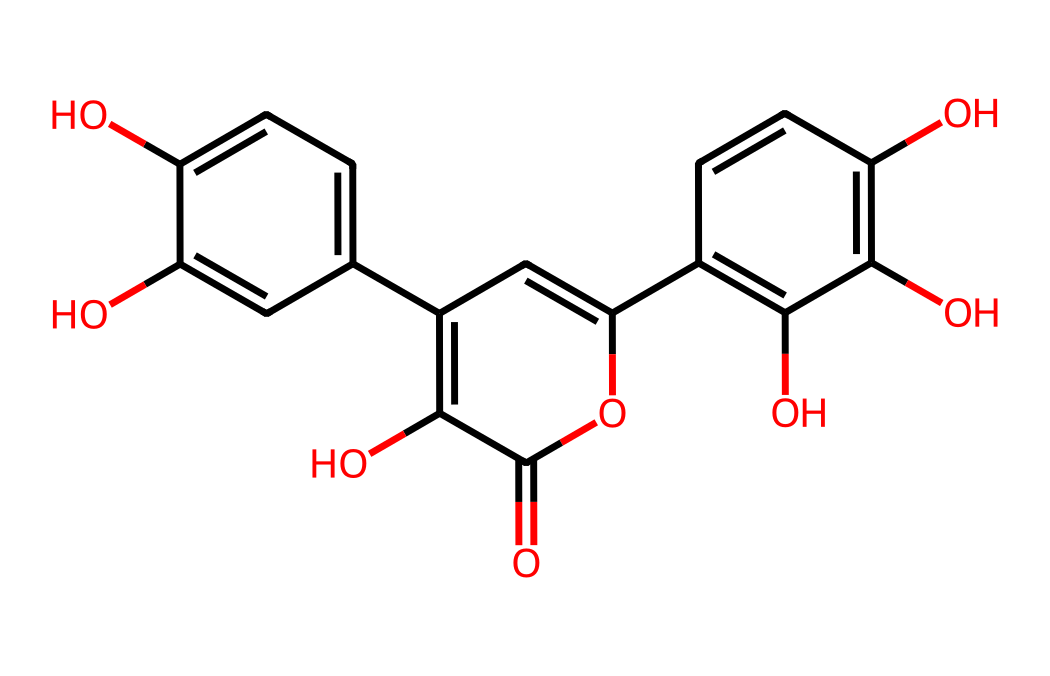What is the name of this chemical? The SMILES representation corresponds to the compound quercetin, which is recognized as a flavonoid antioxidant.
Answer: quercetin How many hydroxyl groups are present in the structure? Upon analyzing the structural formula represented by the SMILES, there are a total of five -OH groups, as indicated by the 'O' atoms linked to carbon atoms throughout the structure.
Answer: five What is the molecular weight of quercetin? The molecular formula derived from the structure is C15H10O7. Calculating the molecular weight involves summing the weights of the constituent atoms (C=12, H=1, O=16) resulting in approximately 302.24 g/mol.
Answer: 302.24 g/mol What type of bond connects the carbon atoms in this compound? The carbon atoms in this compound predominantly form single and double covalent bonds, which can be inferred from the alternating structure and positioning of atoms in the SMILES notation.
Answer: covalent bonds How many rings are present in the structure? The chemical structure reveals the presence of three distinct ring structures, as evident from their cyclic formations in the representation.
Answer: three What is the most notable antioxidant property of quercetin? Quercetin primarily exhibits free radical scavenging ability, allowing it to neutralize reactive oxygen species in the body, which is a key aspect of its antioxidant function.
Answer: free radical scavenging ability 